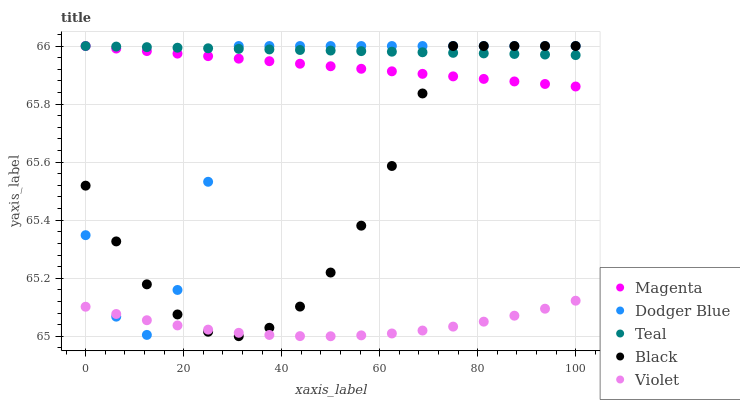Does Violet have the minimum area under the curve?
Answer yes or no. Yes. Does Teal have the maximum area under the curve?
Answer yes or no. Yes. Does Magenta have the minimum area under the curve?
Answer yes or no. No. Does Magenta have the maximum area under the curve?
Answer yes or no. No. Is Magenta the smoothest?
Answer yes or no. Yes. Is Dodger Blue the roughest?
Answer yes or no. Yes. Is Dodger Blue the smoothest?
Answer yes or no. No. Is Magenta the roughest?
Answer yes or no. No. Does Violet have the lowest value?
Answer yes or no. Yes. Does Magenta have the lowest value?
Answer yes or no. No. Does Teal have the highest value?
Answer yes or no. Yes. Does Violet have the highest value?
Answer yes or no. No. Is Violet less than Teal?
Answer yes or no. Yes. Is Magenta greater than Violet?
Answer yes or no. Yes. Does Black intersect Violet?
Answer yes or no. Yes. Is Black less than Violet?
Answer yes or no. No. Is Black greater than Violet?
Answer yes or no. No. Does Violet intersect Teal?
Answer yes or no. No. 